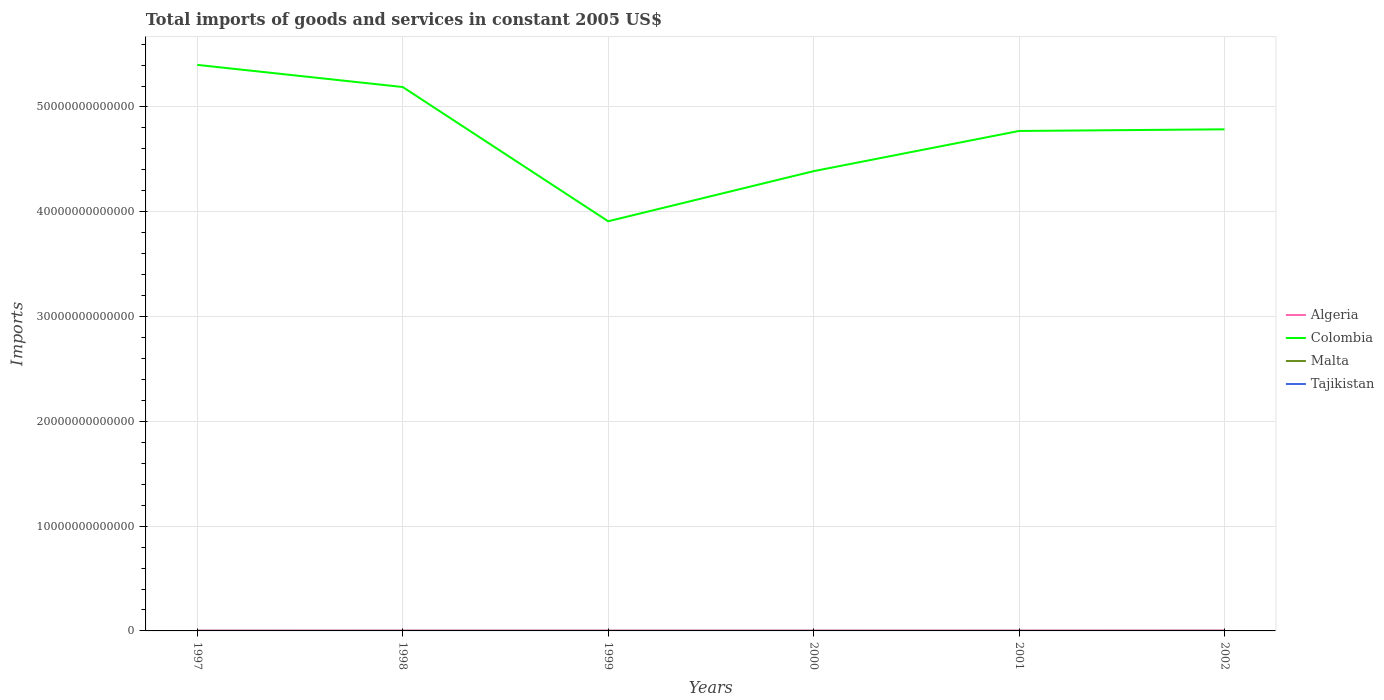How many different coloured lines are there?
Offer a terse response. 4. Is the number of lines equal to the number of legend labels?
Offer a terse response. Yes. Across all years, what is the maximum total imports of goods and services in Colombia?
Give a very brief answer. 3.91e+13. In which year was the total imports of goods and services in Colombia maximum?
Make the answer very short. 1999. What is the total total imports of goods and services in Tajikistan in the graph?
Keep it short and to the point. 4.27e+07. What is the difference between the highest and the second highest total imports of goods and services in Malta?
Offer a very short reply. 4.54e+08. What is the difference between the highest and the lowest total imports of goods and services in Colombia?
Keep it short and to the point. 4. Is the total imports of goods and services in Algeria strictly greater than the total imports of goods and services in Colombia over the years?
Ensure brevity in your answer.  Yes. What is the difference between two consecutive major ticks on the Y-axis?
Provide a short and direct response. 1.00e+13. How many legend labels are there?
Provide a succinct answer. 4. How are the legend labels stacked?
Your answer should be compact. Vertical. What is the title of the graph?
Provide a succinct answer. Total imports of goods and services in constant 2005 US$. Does "Curacao" appear as one of the legend labels in the graph?
Ensure brevity in your answer.  No. What is the label or title of the X-axis?
Your answer should be compact. Years. What is the label or title of the Y-axis?
Keep it short and to the point. Imports. What is the Imports of Algeria in 1997?
Make the answer very short. 3.02e+1. What is the Imports in Colombia in 1997?
Keep it short and to the point. 5.40e+13. What is the Imports in Malta in 1997?
Your response must be concise. 3.81e+09. What is the Imports in Tajikistan in 1997?
Your answer should be very brief. 1.43e+09. What is the Imports of Algeria in 1998?
Provide a succinct answer. 3.25e+1. What is the Imports of Colombia in 1998?
Your response must be concise. 5.19e+13. What is the Imports of Malta in 1998?
Your answer should be very brief. 3.91e+09. What is the Imports of Tajikistan in 1998?
Your answer should be very brief. 1.58e+09. What is the Imports in Algeria in 1999?
Provide a short and direct response. 3.30e+1. What is the Imports in Colombia in 1999?
Your answer should be compact. 3.91e+13. What is the Imports of Malta in 1999?
Provide a short and direct response. 3.91e+09. What is the Imports of Tajikistan in 1999?
Your answer should be compact. 1.63e+09. What is the Imports in Algeria in 2000?
Offer a terse response. 3.27e+1. What is the Imports of Colombia in 2000?
Your response must be concise. 4.39e+13. What is the Imports in Malta in 2000?
Make the answer very short. 3.89e+09. What is the Imports in Tajikistan in 2000?
Provide a short and direct response. 1.80e+09. What is the Imports of Algeria in 2001?
Your answer should be very brief. 3.40e+1. What is the Imports in Colombia in 2001?
Offer a terse response. 4.77e+13. What is the Imports in Malta in 2001?
Give a very brief answer. 3.46e+09. What is the Imports in Tajikistan in 2001?
Ensure brevity in your answer.  1.54e+09. What is the Imports in Algeria in 2002?
Offer a very short reply. 4.06e+1. What is the Imports in Colombia in 2002?
Provide a succinct answer. 4.79e+13. What is the Imports of Malta in 2002?
Give a very brief answer. 3.47e+09. What is the Imports of Tajikistan in 2002?
Make the answer very short. 1.71e+09. Across all years, what is the maximum Imports in Algeria?
Your answer should be very brief. 4.06e+1. Across all years, what is the maximum Imports in Colombia?
Your response must be concise. 5.40e+13. Across all years, what is the maximum Imports of Malta?
Your answer should be very brief. 3.91e+09. Across all years, what is the maximum Imports in Tajikistan?
Your response must be concise. 1.80e+09. Across all years, what is the minimum Imports of Algeria?
Ensure brevity in your answer.  3.02e+1. Across all years, what is the minimum Imports in Colombia?
Make the answer very short. 3.91e+13. Across all years, what is the minimum Imports of Malta?
Your answer should be very brief. 3.46e+09. Across all years, what is the minimum Imports in Tajikistan?
Offer a terse response. 1.43e+09. What is the total Imports of Algeria in the graph?
Provide a short and direct response. 2.03e+11. What is the total Imports in Colombia in the graph?
Your response must be concise. 2.84e+14. What is the total Imports of Malta in the graph?
Your response must be concise. 2.25e+1. What is the total Imports in Tajikistan in the graph?
Your answer should be very brief. 9.70e+09. What is the difference between the Imports of Algeria in 1997 and that in 1998?
Ensure brevity in your answer.  -2.21e+09. What is the difference between the Imports in Colombia in 1997 and that in 1998?
Provide a short and direct response. 2.11e+12. What is the difference between the Imports of Malta in 1997 and that in 1998?
Provide a succinct answer. -9.69e+07. What is the difference between the Imports of Tajikistan in 1997 and that in 1998?
Make the answer very short. -1.58e+08. What is the difference between the Imports of Algeria in 1997 and that in 1999?
Provide a short and direct response. -2.76e+09. What is the difference between the Imports in Colombia in 1997 and that in 1999?
Keep it short and to the point. 1.49e+13. What is the difference between the Imports in Malta in 1997 and that in 1999?
Your answer should be very brief. -9.65e+07. What is the difference between the Imports of Tajikistan in 1997 and that in 1999?
Offer a terse response. -2.07e+08. What is the difference between the Imports of Algeria in 1997 and that in 2000?
Offer a terse response. -2.46e+09. What is the difference between the Imports in Colombia in 1997 and that in 2000?
Your response must be concise. 1.01e+13. What is the difference between the Imports in Malta in 1997 and that in 2000?
Your response must be concise. -7.56e+07. What is the difference between the Imports in Tajikistan in 1997 and that in 2000?
Provide a succinct answer. -3.77e+08. What is the difference between the Imports in Algeria in 1997 and that in 2001?
Keep it short and to the point. -3.74e+09. What is the difference between the Imports of Colombia in 1997 and that in 2001?
Make the answer very short. 6.31e+12. What is the difference between the Imports in Malta in 1997 and that in 2001?
Offer a very short reply. 3.57e+08. What is the difference between the Imports in Tajikistan in 1997 and that in 2001?
Offer a very short reply. -1.16e+08. What is the difference between the Imports of Algeria in 1997 and that in 2002?
Your response must be concise. -1.04e+1. What is the difference between the Imports in Colombia in 1997 and that in 2002?
Ensure brevity in your answer.  6.15e+12. What is the difference between the Imports in Malta in 1997 and that in 2002?
Your response must be concise. 3.41e+08. What is the difference between the Imports of Tajikistan in 1997 and that in 2002?
Offer a terse response. -2.87e+08. What is the difference between the Imports in Algeria in 1998 and that in 1999?
Offer a very short reply. -5.52e+08. What is the difference between the Imports of Colombia in 1998 and that in 1999?
Offer a terse response. 1.28e+13. What is the difference between the Imports of Malta in 1998 and that in 1999?
Ensure brevity in your answer.  3.76e+05. What is the difference between the Imports of Tajikistan in 1998 and that in 1999?
Provide a succinct answer. -4.87e+07. What is the difference between the Imports in Algeria in 1998 and that in 2000?
Provide a short and direct response. -2.55e+08. What is the difference between the Imports in Colombia in 1998 and that in 2000?
Offer a terse response. 8.03e+12. What is the difference between the Imports in Malta in 1998 and that in 2000?
Provide a succinct answer. 2.13e+07. What is the difference between the Imports of Tajikistan in 1998 and that in 2000?
Provide a succinct answer. -2.19e+08. What is the difference between the Imports in Algeria in 1998 and that in 2001?
Provide a short and direct response. -1.53e+09. What is the difference between the Imports of Colombia in 1998 and that in 2001?
Offer a terse response. 4.19e+12. What is the difference between the Imports in Malta in 1998 and that in 2001?
Your answer should be compact. 4.54e+08. What is the difference between the Imports of Tajikistan in 1998 and that in 2001?
Your answer should be very brief. 4.27e+07. What is the difference between the Imports of Algeria in 1998 and that in 2002?
Provide a succinct answer. -8.16e+09. What is the difference between the Imports in Colombia in 1998 and that in 2002?
Keep it short and to the point. 4.04e+12. What is the difference between the Imports in Malta in 1998 and that in 2002?
Your response must be concise. 4.38e+08. What is the difference between the Imports of Tajikistan in 1998 and that in 2002?
Keep it short and to the point. -1.28e+08. What is the difference between the Imports in Algeria in 1999 and that in 2000?
Provide a short and direct response. 2.97e+08. What is the difference between the Imports in Colombia in 1999 and that in 2000?
Provide a succinct answer. -4.78e+12. What is the difference between the Imports in Malta in 1999 and that in 2000?
Your answer should be very brief. 2.09e+07. What is the difference between the Imports in Tajikistan in 1999 and that in 2000?
Offer a very short reply. -1.70e+08. What is the difference between the Imports of Algeria in 1999 and that in 2001?
Give a very brief answer. -9.79e+08. What is the difference between the Imports in Colombia in 1999 and that in 2001?
Provide a succinct answer. -8.62e+12. What is the difference between the Imports of Malta in 1999 and that in 2001?
Your response must be concise. 4.54e+08. What is the difference between the Imports in Tajikistan in 1999 and that in 2001?
Your answer should be compact. 9.14e+07. What is the difference between the Imports in Algeria in 1999 and that in 2002?
Your answer should be very brief. -7.61e+09. What is the difference between the Imports in Colombia in 1999 and that in 2002?
Offer a very short reply. -8.77e+12. What is the difference between the Imports in Malta in 1999 and that in 2002?
Keep it short and to the point. 4.37e+08. What is the difference between the Imports of Tajikistan in 1999 and that in 2002?
Offer a terse response. -7.97e+07. What is the difference between the Imports in Algeria in 2000 and that in 2001?
Make the answer very short. -1.28e+09. What is the difference between the Imports in Colombia in 2000 and that in 2001?
Offer a very short reply. -3.84e+12. What is the difference between the Imports in Malta in 2000 and that in 2001?
Your answer should be compact. 4.33e+08. What is the difference between the Imports in Tajikistan in 2000 and that in 2001?
Your answer should be very brief. 2.61e+08. What is the difference between the Imports of Algeria in 2000 and that in 2002?
Keep it short and to the point. -7.90e+09. What is the difference between the Imports in Colombia in 2000 and that in 2002?
Provide a short and direct response. -3.99e+12. What is the difference between the Imports in Malta in 2000 and that in 2002?
Provide a short and direct response. 4.16e+08. What is the difference between the Imports in Tajikistan in 2000 and that in 2002?
Provide a succinct answer. 9.03e+07. What is the difference between the Imports in Algeria in 2001 and that in 2002?
Your answer should be very brief. -6.63e+09. What is the difference between the Imports in Colombia in 2001 and that in 2002?
Give a very brief answer. -1.57e+11. What is the difference between the Imports of Malta in 2001 and that in 2002?
Your response must be concise. -1.65e+07. What is the difference between the Imports of Tajikistan in 2001 and that in 2002?
Give a very brief answer. -1.71e+08. What is the difference between the Imports of Algeria in 1997 and the Imports of Colombia in 1998?
Make the answer very short. -5.19e+13. What is the difference between the Imports in Algeria in 1997 and the Imports in Malta in 1998?
Offer a terse response. 2.63e+1. What is the difference between the Imports of Algeria in 1997 and the Imports of Tajikistan in 1998?
Your response must be concise. 2.87e+1. What is the difference between the Imports of Colombia in 1997 and the Imports of Malta in 1998?
Give a very brief answer. 5.40e+13. What is the difference between the Imports of Colombia in 1997 and the Imports of Tajikistan in 1998?
Your answer should be very brief. 5.40e+13. What is the difference between the Imports of Malta in 1997 and the Imports of Tajikistan in 1998?
Your answer should be compact. 2.23e+09. What is the difference between the Imports in Algeria in 1997 and the Imports in Colombia in 1999?
Your answer should be very brief. -3.91e+13. What is the difference between the Imports of Algeria in 1997 and the Imports of Malta in 1999?
Provide a succinct answer. 2.63e+1. What is the difference between the Imports in Algeria in 1997 and the Imports in Tajikistan in 1999?
Offer a terse response. 2.86e+1. What is the difference between the Imports in Colombia in 1997 and the Imports in Malta in 1999?
Provide a succinct answer. 5.40e+13. What is the difference between the Imports of Colombia in 1997 and the Imports of Tajikistan in 1999?
Your response must be concise. 5.40e+13. What is the difference between the Imports in Malta in 1997 and the Imports in Tajikistan in 1999?
Offer a terse response. 2.18e+09. What is the difference between the Imports in Algeria in 1997 and the Imports in Colombia in 2000?
Your answer should be very brief. -4.38e+13. What is the difference between the Imports in Algeria in 1997 and the Imports in Malta in 2000?
Your response must be concise. 2.64e+1. What is the difference between the Imports of Algeria in 1997 and the Imports of Tajikistan in 2000?
Offer a terse response. 2.84e+1. What is the difference between the Imports in Colombia in 1997 and the Imports in Malta in 2000?
Provide a succinct answer. 5.40e+13. What is the difference between the Imports of Colombia in 1997 and the Imports of Tajikistan in 2000?
Ensure brevity in your answer.  5.40e+13. What is the difference between the Imports in Malta in 1997 and the Imports in Tajikistan in 2000?
Your answer should be very brief. 2.01e+09. What is the difference between the Imports in Algeria in 1997 and the Imports in Colombia in 2001?
Give a very brief answer. -4.77e+13. What is the difference between the Imports in Algeria in 1997 and the Imports in Malta in 2001?
Offer a terse response. 2.68e+1. What is the difference between the Imports of Algeria in 1997 and the Imports of Tajikistan in 2001?
Give a very brief answer. 2.87e+1. What is the difference between the Imports in Colombia in 1997 and the Imports in Malta in 2001?
Your response must be concise. 5.40e+13. What is the difference between the Imports of Colombia in 1997 and the Imports of Tajikistan in 2001?
Offer a very short reply. 5.40e+13. What is the difference between the Imports of Malta in 1997 and the Imports of Tajikistan in 2001?
Keep it short and to the point. 2.27e+09. What is the difference between the Imports in Algeria in 1997 and the Imports in Colombia in 2002?
Your response must be concise. -4.78e+13. What is the difference between the Imports of Algeria in 1997 and the Imports of Malta in 2002?
Your answer should be very brief. 2.68e+1. What is the difference between the Imports in Algeria in 1997 and the Imports in Tajikistan in 2002?
Your answer should be very brief. 2.85e+1. What is the difference between the Imports of Colombia in 1997 and the Imports of Malta in 2002?
Provide a short and direct response. 5.40e+13. What is the difference between the Imports in Colombia in 1997 and the Imports in Tajikistan in 2002?
Offer a very short reply. 5.40e+13. What is the difference between the Imports of Malta in 1997 and the Imports of Tajikistan in 2002?
Offer a very short reply. 2.10e+09. What is the difference between the Imports of Algeria in 1998 and the Imports of Colombia in 1999?
Keep it short and to the point. -3.91e+13. What is the difference between the Imports of Algeria in 1998 and the Imports of Malta in 1999?
Ensure brevity in your answer.  2.85e+1. What is the difference between the Imports in Algeria in 1998 and the Imports in Tajikistan in 1999?
Keep it short and to the point. 3.08e+1. What is the difference between the Imports of Colombia in 1998 and the Imports of Malta in 1999?
Make the answer very short. 5.19e+13. What is the difference between the Imports in Colombia in 1998 and the Imports in Tajikistan in 1999?
Give a very brief answer. 5.19e+13. What is the difference between the Imports of Malta in 1998 and the Imports of Tajikistan in 1999?
Your answer should be very brief. 2.28e+09. What is the difference between the Imports of Algeria in 1998 and the Imports of Colombia in 2000?
Give a very brief answer. -4.38e+13. What is the difference between the Imports in Algeria in 1998 and the Imports in Malta in 2000?
Ensure brevity in your answer.  2.86e+1. What is the difference between the Imports of Algeria in 1998 and the Imports of Tajikistan in 2000?
Provide a short and direct response. 3.06e+1. What is the difference between the Imports of Colombia in 1998 and the Imports of Malta in 2000?
Your response must be concise. 5.19e+13. What is the difference between the Imports of Colombia in 1998 and the Imports of Tajikistan in 2000?
Your answer should be compact. 5.19e+13. What is the difference between the Imports of Malta in 1998 and the Imports of Tajikistan in 2000?
Give a very brief answer. 2.11e+09. What is the difference between the Imports in Algeria in 1998 and the Imports in Colombia in 2001?
Keep it short and to the point. -4.77e+13. What is the difference between the Imports in Algeria in 1998 and the Imports in Malta in 2001?
Provide a succinct answer. 2.90e+1. What is the difference between the Imports in Algeria in 1998 and the Imports in Tajikistan in 2001?
Make the answer very short. 3.09e+1. What is the difference between the Imports of Colombia in 1998 and the Imports of Malta in 2001?
Offer a very short reply. 5.19e+13. What is the difference between the Imports in Colombia in 1998 and the Imports in Tajikistan in 2001?
Your response must be concise. 5.19e+13. What is the difference between the Imports of Malta in 1998 and the Imports of Tajikistan in 2001?
Provide a short and direct response. 2.37e+09. What is the difference between the Imports in Algeria in 1998 and the Imports in Colombia in 2002?
Keep it short and to the point. -4.78e+13. What is the difference between the Imports of Algeria in 1998 and the Imports of Malta in 2002?
Provide a short and direct response. 2.90e+1. What is the difference between the Imports in Algeria in 1998 and the Imports in Tajikistan in 2002?
Your response must be concise. 3.07e+1. What is the difference between the Imports in Colombia in 1998 and the Imports in Malta in 2002?
Offer a very short reply. 5.19e+13. What is the difference between the Imports of Colombia in 1998 and the Imports of Tajikistan in 2002?
Offer a very short reply. 5.19e+13. What is the difference between the Imports in Malta in 1998 and the Imports in Tajikistan in 2002?
Offer a terse response. 2.20e+09. What is the difference between the Imports of Algeria in 1999 and the Imports of Colombia in 2000?
Keep it short and to the point. -4.38e+13. What is the difference between the Imports in Algeria in 1999 and the Imports in Malta in 2000?
Make the answer very short. 2.91e+1. What is the difference between the Imports of Algeria in 1999 and the Imports of Tajikistan in 2000?
Keep it short and to the point. 3.12e+1. What is the difference between the Imports of Colombia in 1999 and the Imports of Malta in 2000?
Ensure brevity in your answer.  3.91e+13. What is the difference between the Imports of Colombia in 1999 and the Imports of Tajikistan in 2000?
Give a very brief answer. 3.91e+13. What is the difference between the Imports in Malta in 1999 and the Imports in Tajikistan in 2000?
Your response must be concise. 2.11e+09. What is the difference between the Imports in Algeria in 1999 and the Imports in Colombia in 2001?
Make the answer very short. -4.77e+13. What is the difference between the Imports in Algeria in 1999 and the Imports in Malta in 2001?
Give a very brief answer. 2.95e+1. What is the difference between the Imports in Algeria in 1999 and the Imports in Tajikistan in 2001?
Keep it short and to the point. 3.15e+1. What is the difference between the Imports in Colombia in 1999 and the Imports in Malta in 2001?
Ensure brevity in your answer.  3.91e+13. What is the difference between the Imports of Colombia in 1999 and the Imports of Tajikistan in 2001?
Give a very brief answer. 3.91e+13. What is the difference between the Imports in Malta in 1999 and the Imports in Tajikistan in 2001?
Ensure brevity in your answer.  2.37e+09. What is the difference between the Imports of Algeria in 1999 and the Imports of Colombia in 2002?
Provide a short and direct response. -4.78e+13. What is the difference between the Imports in Algeria in 1999 and the Imports in Malta in 2002?
Offer a very short reply. 2.95e+1. What is the difference between the Imports of Algeria in 1999 and the Imports of Tajikistan in 2002?
Your answer should be very brief. 3.13e+1. What is the difference between the Imports of Colombia in 1999 and the Imports of Malta in 2002?
Ensure brevity in your answer.  3.91e+13. What is the difference between the Imports in Colombia in 1999 and the Imports in Tajikistan in 2002?
Your answer should be very brief. 3.91e+13. What is the difference between the Imports in Malta in 1999 and the Imports in Tajikistan in 2002?
Give a very brief answer. 2.20e+09. What is the difference between the Imports of Algeria in 2000 and the Imports of Colombia in 2001?
Give a very brief answer. -4.77e+13. What is the difference between the Imports in Algeria in 2000 and the Imports in Malta in 2001?
Provide a short and direct response. 2.93e+1. What is the difference between the Imports of Algeria in 2000 and the Imports of Tajikistan in 2001?
Ensure brevity in your answer.  3.12e+1. What is the difference between the Imports of Colombia in 2000 and the Imports of Malta in 2001?
Ensure brevity in your answer.  4.39e+13. What is the difference between the Imports of Colombia in 2000 and the Imports of Tajikistan in 2001?
Offer a terse response. 4.39e+13. What is the difference between the Imports of Malta in 2000 and the Imports of Tajikistan in 2001?
Give a very brief answer. 2.35e+09. What is the difference between the Imports of Algeria in 2000 and the Imports of Colombia in 2002?
Offer a very short reply. -4.78e+13. What is the difference between the Imports of Algeria in 2000 and the Imports of Malta in 2002?
Offer a terse response. 2.92e+1. What is the difference between the Imports of Algeria in 2000 and the Imports of Tajikistan in 2002?
Offer a very short reply. 3.10e+1. What is the difference between the Imports in Colombia in 2000 and the Imports in Malta in 2002?
Offer a very short reply. 4.39e+13. What is the difference between the Imports of Colombia in 2000 and the Imports of Tajikistan in 2002?
Ensure brevity in your answer.  4.39e+13. What is the difference between the Imports of Malta in 2000 and the Imports of Tajikistan in 2002?
Offer a very short reply. 2.18e+09. What is the difference between the Imports of Algeria in 2001 and the Imports of Colombia in 2002?
Provide a short and direct response. -4.78e+13. What is the difference between the Imports of Algeria in 2001 and the Imports of Malta in 2002?
Offer a terse response. 3.05e+1. What is the difference between the Imports of Algeria in 2001 and the Imports of Tajikistan in 2002?
Your response must be concise. 3.23e+1. What is the difference between the Imports in Colombia in 2001 and the Imports in Malta in 2002?
Provide a short and direct response. 4.77e+13. What is the difference between the Imports of Colombia in 2001 and the Imports of Tajikistan in 2002?
Your answer should be compact. 4.77e+13. What is the difference between the Imports of Malta in 2001 and the Imports of Tajikistan in 2002?
Your answer should be compact. 1.74e+09. What is the average Imports in Algeria per year?
Ensure brevity in your answer.  3.38e+1. What is the average Imports in Colombia per year?
Make the answer very short. 4.74e+13. What is the average Imports of Malta per year?
Offer a terse response. 3.74e+09. What is the average Imports of Tajikistan per year?
Make the answer very short. 1.62e+09. In the year 1997, what is the difference between the Imports of Algeria and Imports of Colombia?
Ensure brevity in your answer.  -5.40e+13. In the year 1997, what is the difference between the Imports of Algeria and Imports of Malta?
Keep it short and to the point. 2.64e+1. In the year 1997, what is the difference between the Imports of Algeria and Imports of Tajikistan?
Your answer should be very brief. 2.88e+1. In the year 1997, what is the difference between the Imports of Colombia and Imports of Malta?
Offer a very short reply. 5.40e+13. In the year 1997, what is the difference between the Imports in Colombia and Imports in Tajikistan?
Offer a very short reply. 5.40e+13. In the year 1997, what is the difference between the Imports in Malta and Imports in Tajikistan?
Your answer should be very brief. 2.39e+09. In the year 1998, what is the difference between the Imports in Algeria and Imports in Colombia?
Provide a succinct answer. -5.19e+13. In the year 1998, what is the difference between the Imports in Algeria and Imports in Malta?
Give a very brief answer. 2.85e+1. In the year 1998, what is the difference between the Imports of Algeria and Imports of Tajikistan?
Provide a short and direct response. 3.09e+1. In the year 1998, what is the difference between the Imports in Colombia and Imports in Malta?
Offer a terse response. 5.19e+13. In the year 1998, what is the difference between the Imports of Colombia and Imports of Tajikistan?
Your answer should be very brief. 5.19e+13. In the year 1998, what is the difference between the Imports of Malta and Imports of Tajikistan?
Offer a terse response. 2.33e+09. In the year 1999, what is the difference between the Imports in Algeria and Imports in Colombia?
Your answer should be compact. -3.91e+13. In the year 1999, what is the difference between the Imports in Algeria and Imports in Malta?
Provide a succinct answer. 2.91e+1. In the year 1999, what is the difference between the Imports of Algeria and Imports of Tajikistan?
Your answer should be compact. 3.14e+1. In the year 1999, what is the difference between the Imports in Colombia and Imports in Malta?
Give a very brief answer. 3.91e+13. In the year 1999, what is the difference between the Imports of Colombia and Imports of Tajikistan?
Make the answer very short. 3.91e+13. In the year 1999, what is the difference between the Imports of Malta and Imports of Tajikistan?
Your answer should be very brief. 2.28e+09. In the year 2000, what is the difference between the Imports in Algeria and Imports in Colombia?
Ensure brevity in your answer.  -4.38e+13. In the year 2000, what is the difference between the Imports in Algeria and Imports in Malta?
Keep it short and to the point. 2.88e+1. In the year 2000, what is the difference between the Imports in Algeria and Imports in Tajikistan?
Your response must be concise. 3.09e+1. In the year 2000, what is the difference between the Imports in Colombia and Imports in Malta?
Offer a very short reply. 4.39e+13. In the year 2000, what is the difference between the Imports in Colombia and Imports in Tajikistan?
Make the answer very short. 4.39e+13. In the year 2000, what is the difference between the Imports of Malta and Imports of Tajikistan?
Provide a short and direct response. 2.09e+09. In the year 2001, what is the difference between the Imports of Algeria and Imports of Colombia?
Make the answer very short. -4.77e+13. In the year 2001, what is the difference between the Imports in Algeria and Imports in Malta?
Offer a very short reply. 3.05e+1. In the year 2001, what is the difference between the Imports in Algeria and Imports in Tajikistan?
Offer a very short reply. 3.24e+1. In the year 2001, what is the difference between the Imports in Colombia and Imports in Malta?
Your answer should be compact. 4.77e+13. In the year 2001, what is the difference between the Imports in Colombia and Imports in Tajikistan?
Make the answer very short. 4.77e+13. In the year 2001, what is the difference between the Imports in Malta and Imports in Tajikistan?
Provide a short and direct response. 1.92e+09. In the year 2002, what is the difference between the Imports of Algeria and Imports of Colombia?
Ensure brevity in your answer.  -4.78e+13. In the year 2002, what is the difference between the Imports in Algeria and Imports in Malta?
Offer a terse response. 3.71e+1. In the year 2002, what is the difference between the Imports in Algeria and Imports in Tajikistan?
Provide a succinct answer. 3.89e+1. In the year 2002, what is the difference between the Imports of Colombia and Imports of Malta?
Keep it short and to the point. 4.79e+13. In the year 2002, what is the difference between the Imports of Colombia and Imports of Tajikistan?
Offer a terse response. 4.79e+13. In the year 2002, what is the difference between the Imports of Malta and Imports of Tajikistan?
Your answer should be compact. 1.76e+09. What is the ratio of the Imports in Algeria in 1997 to that in 1998?
Ensure brevity in your answer.  0.93. What is the ratio of the Imports in Colombia in 1997 to that in 1998?
Make the answer very short. 1.04. What is the ratio of the Imports of Malta in 1997 to that in 1998?
Your response must be concise. 0.98. What is the ratio of the Imports in Tajikistan in 1997 to that in 1998?
Ensure brevity in your answer.  0.9. What is the ratio of the Imports of Algeria in 1997 to that in 1999?
Provide a short and direct response. 0.92. What is the ratio of the Imports of Colombia in 1997 to that in 1999?
Your answer should be very brief. 1.38. What is the ratio of the Imports in Malta in 1997 to that in 1999?
Ensure brevity in your answer.  0.98. What is the ratio of the Imports in Tajikistan in 1997 to that in 1999?
Your answer should be very brief. 0.87. What is the ratio of the Imports of Algeria in 1997 to that in 2000?
Your answer should be compact. 0.92. What is the ratio of the Imports in Colombia in 1997 to that in 2000?
Your response must be concise. 1.23. What is the ratio of the Imports in Malta in 1997 to that in 2000?
Your response must be concise. 0.98. What is the ratio of the Imports of Tajikistan in 1997 to that in 2000?
Your answer should be very brief. 0.79. What is the ratio of the Imports in Algeria in 1997 to that in 2001?
Offer a terse response. 0.89. What is the ratio of the Imports of Colombia in 1997 to that in 2001?
Offer a very short reply. 1.13. What is the ratio of the Imports of Malta in 1997 to that in 2001?
Give a very brief answer. 1.1. What is the ratio of the Imports in Tajikistan in 1997 to that in 2001?
Your answer should be very brief. 0.93. What is the ratio of the Imports of Algeria in 1997 to that in 2002?
Give a very brief answer. 0.74. What is the ratio of the Imports of Colombia in 1997 to that in 2002?
Make the answer very short. 1.13. What is the ratio of the Imports of Malta in 1997 to that in 2002?
Keep it short and to the point. 1.1. What is the ratio of the Imports in Tajikistan in 1997 to that in 2002?
Ensure brevity in your answer.  0.83. What is the ratio of the Imports in Algeria in 1998 to that in 1999?
Provide a short and direct response. 0.98. What is the ratio of the Imports in Colombia in 1998 to that in 1999?
Keep it short and to the point. 1.33. What is the ratio of the Imports in Malta in 1998 to that in 1999?
Provide a succinct answer. 1. What is the ratio of the Imports in Tajikistan in 1998 to that in 1999?
Provide a succinct answer. 0.97. What is the ratio of the Imports of Algeria in 1998 to that in 2000?
Provide a succinct answer. 0.99. What is the ratio of the Imports of Colombia in 1998 to that in 2000?
Your answer should be compact. 1.18. What is the ratio of the Imports of Malta in 1998 to that in 2000?
Your answer should be very brief. 1.01. What is the ratio of the Imports of Tajikistan in 1998 to that in 2000?
Your answer should be very brief. 0.88. What is the ratio of the Imports of Algeria in 1998 to that in 2001?
Ensure brevity in your answer.  0.95. What is the ratio of the Imports of Colombia in 1998 to that in 2001?
Provide a short and direct response. 1.09. What is the ratio of the Imports of Malta in 1998 to that in 2001?
Offer a terse response. 1.13. What is the ratio of the Imports in Tajikistan in 1998 to that in 2001?
Your answer should be compact. 1.03. What is the ratio of the Imports of Algeria in 1998 to that in 2002?
Provide a short and direct response. 0.8. What is the ratio of the Imports of Colombia in 1998 to that in 2002?
Ensure brevity in your answer.  1.08. What is the ratio of the Imports of Malta in 1998 to that in 2002?
Your answer should be very brief. 1.13. What is the ratio of the Imports in Tajikistan in 1998 to that in 2002?
Provide a short and direct response. 0.93. What is the ratio of the Imports in Algeria in 1999 to that in 2000?
Make the answer very short. 1.01. What is the ratio of the Imports in Colombia in 1999 to that in 2000?
Offer a terse response. 0.89. What is the ratio of the Imports of Malta in 1999 to that in 2000?
Your answer should be very brief. 1.01. What is the ratio of the Imports in Tajikistan in 1999 to that in 2000?
Provide a short and direct response. 0.91. What is the ratio of the Imports in Algeria in 1999 to that in 2001?
Your answer should be compact. 0.97. What is the ratio of the Imports in Colombia in 1999 to that in 2001?
Your answer should be very brief. 0.82. What is the ratio of the Imports in Malta in 1999 to that in 2001?
Make the answer very short. 1.13. What is the ratio of the Imports of Tajikistan in 1999 to that in 2001?
Keep it short and to the point. 1.06. What is the ratio of the Imports in Algeria in 1999 to that in 2002?
Make the answer very short. 0.81. What is the ratio of the Imports of Colombia in 1999 to that in 2002?
Offer a very short reply. 0.82. What is the ratio of the Imports in Malta in 1999 to that in 2002?
Ensure brevity in your answer.  1.13. What is the ratio of the Imports of Tajikistan in 1999 to that in 2002?
Offer a terse response. 0.95. What is the ratio of the Imports of Algeria in 2000 to that in 2001?
Give a very brief answer. 0.96. What is the ratio of the Imports in Colombia in 2000 to that in 2001?
Keep it short and to the point. 0.92. What is the ratio of the Imports of Malta in 2000 to that in 2001?
Give a very brief answer. 1.13. What is the ratio of the Imports in Tajikistan in 2000 to that in 2001?
Make the answer very short. 1.17. What is the ratio of the Imports of Algeria in 2000 to that in 2002?
Give a very brief answer. 0.81. What is the ratio of the Imports in Colombia in 2000 to that in 2002?
Make the answer very short. 0.92. What is the ratio of the Imports of Malta in 2000 to that in 2002?
Offer a terse response. 1.12. What is the ratio of the Imports in Tajikistan in 2000 to that in 2002?
Offer a terse response. 1.05. What is the ratio of the Imports in Algeria in 2001 to that in 2002?
Keep it short and to the point. 0.84. What is the ratio of the Imports in Colombia in 2001 to that in 2002?
Your answer should be compact. 1. What is the ratio of the Imports of Malta in 2001 to that in 2002?
Provide a short and direct response. 1. What is the ratio of the Imports of Tajikistan in 2001 to that in 2002?
Offer a very short reply. 0.9. What is the difference between the highest and the second highest Imports of Algeria?
Make the answer very short. 6.63e+09. What is the difference between the highest and the second highest Imports in Colombia?
Provide a short and direct response. 2.11e+12. What is the difference between the highest and the second highest Imports in Malta?
Ensure brevity in your answer.  3.76e+05. What is the difference between the highest and the second highest Imports of Tajikistan?
Your answer should be compact. 9.03e+07. What is the difference between the highest and the lowest Imports of Algeria?
Give a very brief answer. 1.04e+1. What is the difference between the highest and the lowest Imports of Colombia?
Keep it short and to the point. 1.49e+13. What is the difference between the highest and the lowest Imports in Malta?
Your answer should be very brief. 4.54e+08. What is the difference between the highest and the lowest Imports of Tajikistan?
Offer a very short reply. 3.77e+08. 